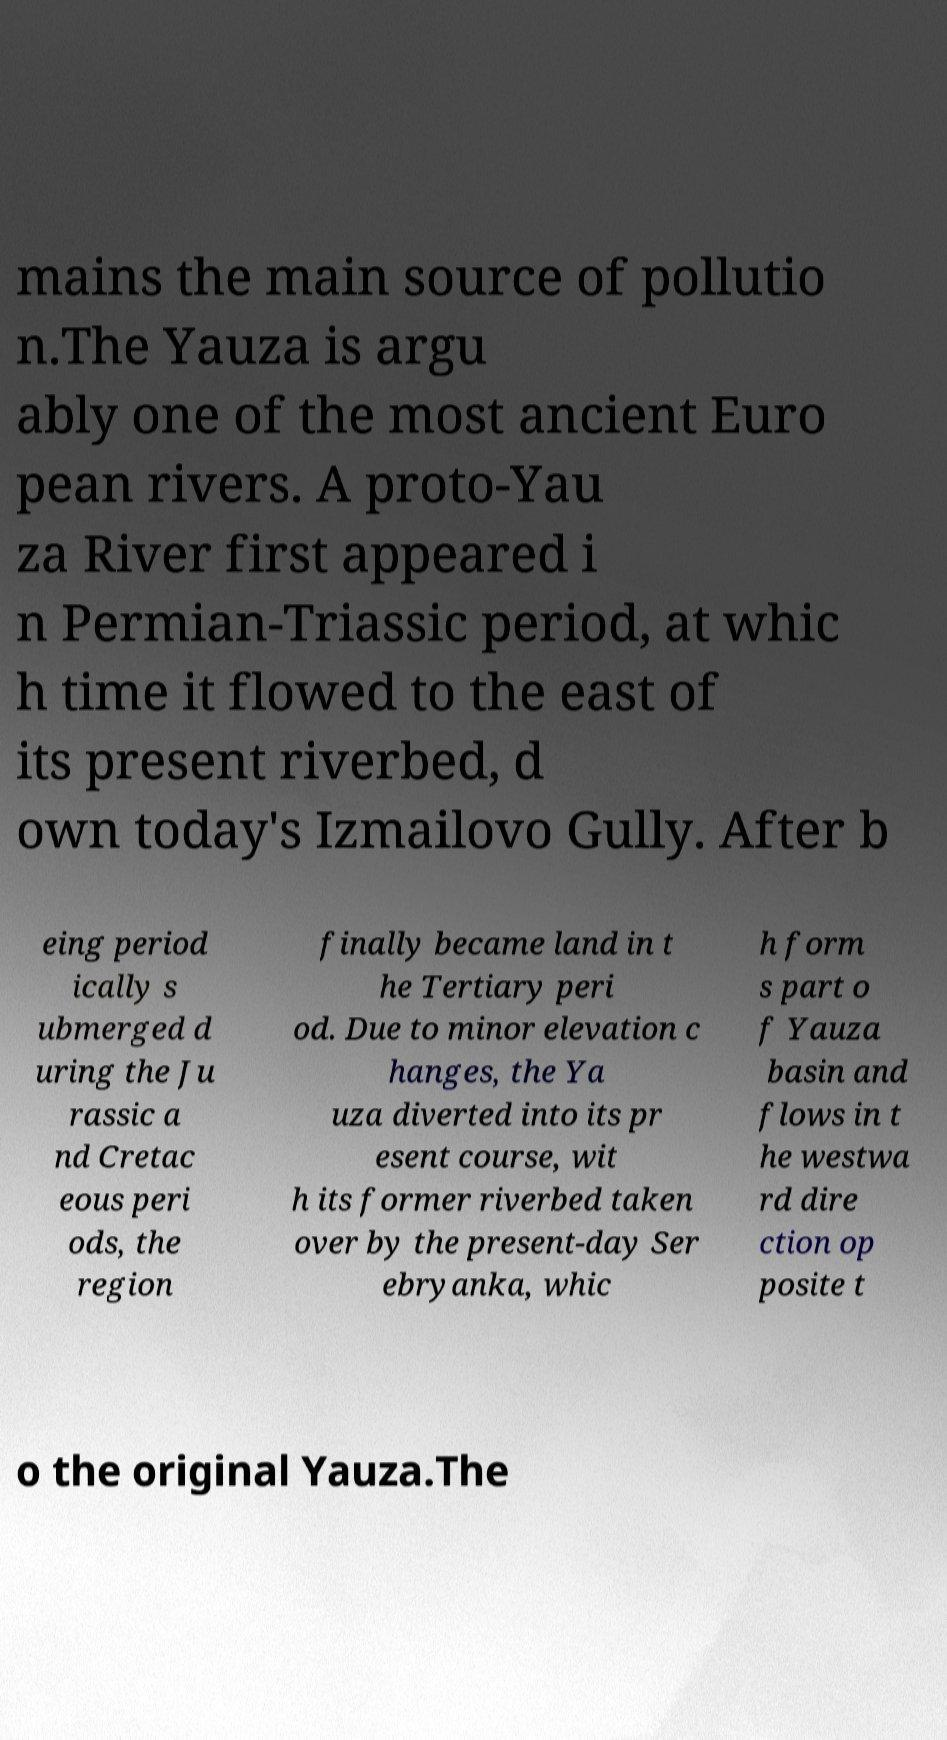There's text embedded in this image that I need extracted. Can you transcribe it verbatim? mains the main source of pollutio n.The Yauza is argu ably one of the most ancient Euro pean rivers. A proto-Yau za River first appeared i n Permian-Triassic period, at whic h time it flowed to the east of its present riverbed, d own today's Izmailovo Gully. After b eing period ically s ubmerged d uring the Ju rassic a nd Cretac eous peri ods, the region finally became land in t he Tertiary peri od. Due to minor elevation c hanges, the Ya uza diverted into its pr esent course, wit h its former riverbed taken over by the present-day Ser ebryanka, whic h form s part o f Yauza basin and flows in t he westwa rd dire ction op posite t o the original Yauza.The 